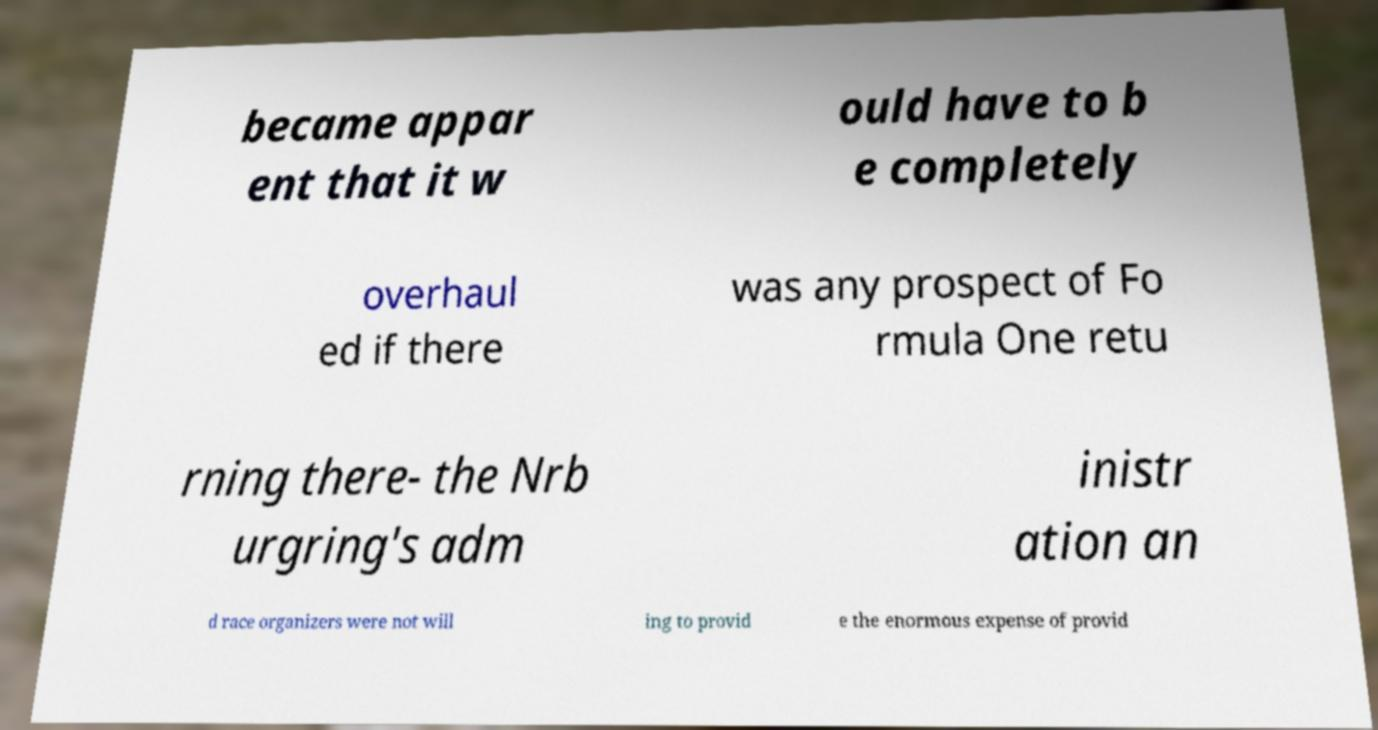For documentation purposes, I need the text within this image transcribed. Could you provide that? became appar ent that it w ould have to b e completely overhaul ed if there was any prospect of Fo rmula One retu rning there- the Nrb urgring's adm inistr ation an d race organizers were not will ing to provid e the enormous expense of provid 